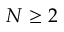Convert formula to latex. <formula><loc_0><loc_0><loc_500><loc_500>N \geq 2</formula> 